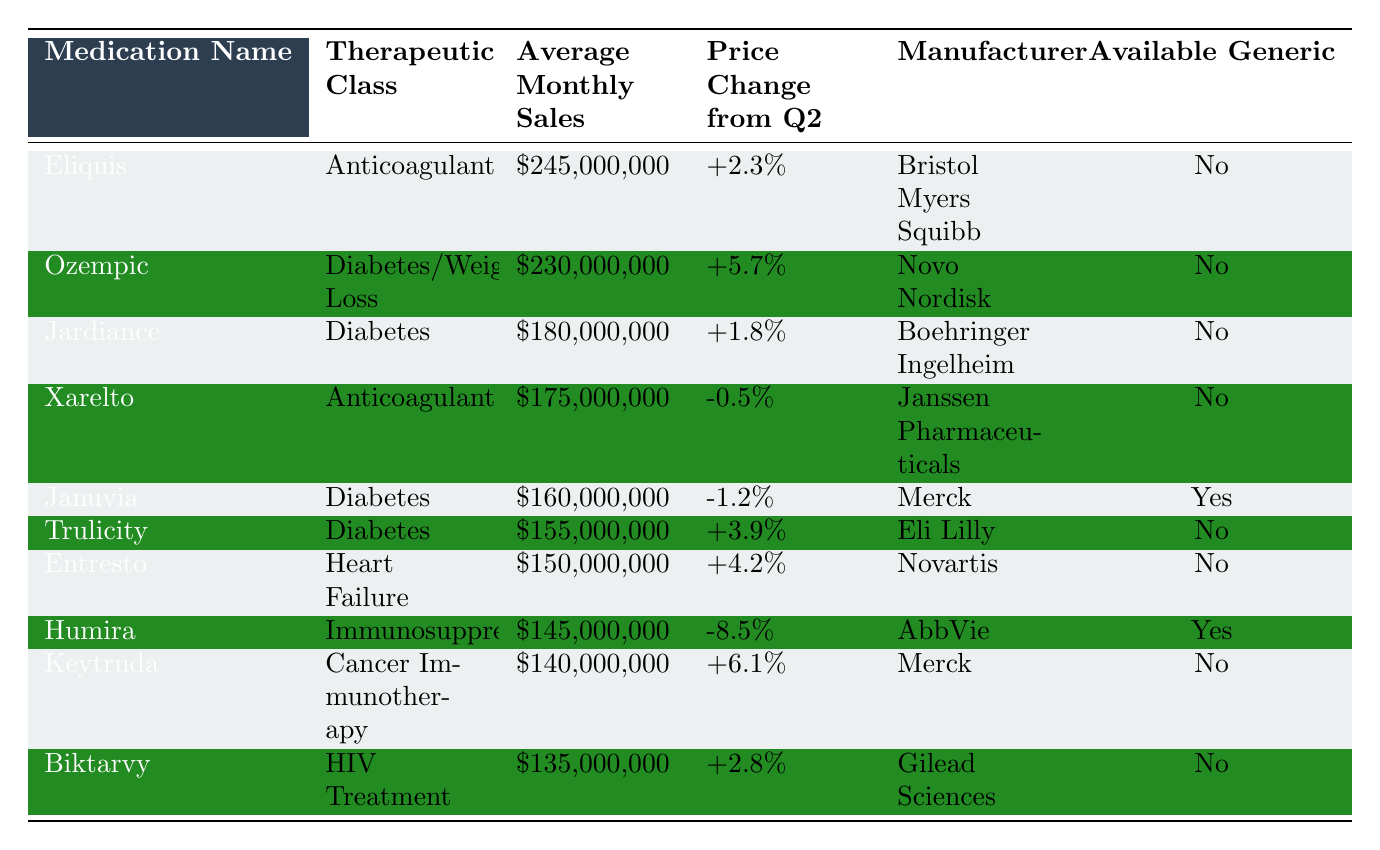What medication has the highest average monthly sales? By reviewing the "Average Monthly Sales" column, we can see that "Eliquis" has the highest value at $245,000,000.
Answer: Eliquis Which therapeutic class does "Humira" belong to? Looking under the "Therapeutic Class" column for "Humira", it is categorized as an "Immunosuppressant".
Answer: Immunosuppressant Was there a price change for "Januvia" from Q2? The "Price Change from Q2" for "Januvia" shows a negative change of -1.2%, indicating a decrease in price.
Answer: Yes How much did "Ozempic" sell in average monthly sales? From the "Average Monthly Sales" column, "Ozempic" has an average of $230,000,000 in sales.
Answer: $230,000,000 Which medication had the largest percentage price increase from Q2? By comparing the "Price Change from Q2" percentages, "Ozempic" with a +5.7% increase is the highest.
Answer: Ozempic Is there a generic version available for "Keytruda"? Checking the "Available Generic" column, we see that "Keytruda" does not have a generic version available.
Answer: No What is the average monthly sales for all diabetes medications listed? The relevant medications are "Jardiance", "Januvia", "Ozempic", and "Trulicity". Their average monthly sales are $180,000,000, $160,000,000, $230,000,000, and $155,000,000 respectively. Adding them gives $725,000,000; dividing by 4 gives an average of $181,250,000.
Answer: $181,250,000 Which medication has the lowest average monthly sales? Scanning the "Average Monthly Sales" values, "Biktarvy" at $135,000,000 has the lowest sales figure.
Answer: Biktarvy Has "Entresto" experienced an increase in price from Q2? The price change for "Entresto" shows a +4.2% increase, indicating it has increased in price.
Answer: Yes Which medication has both a high sales number and an available generic? From the data, "Januvia" has an average monthly sales of $160,000,000 and it is listed as having an available generic.
Answer: Januvia 